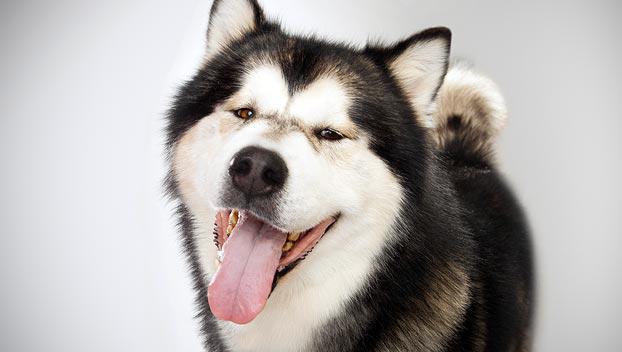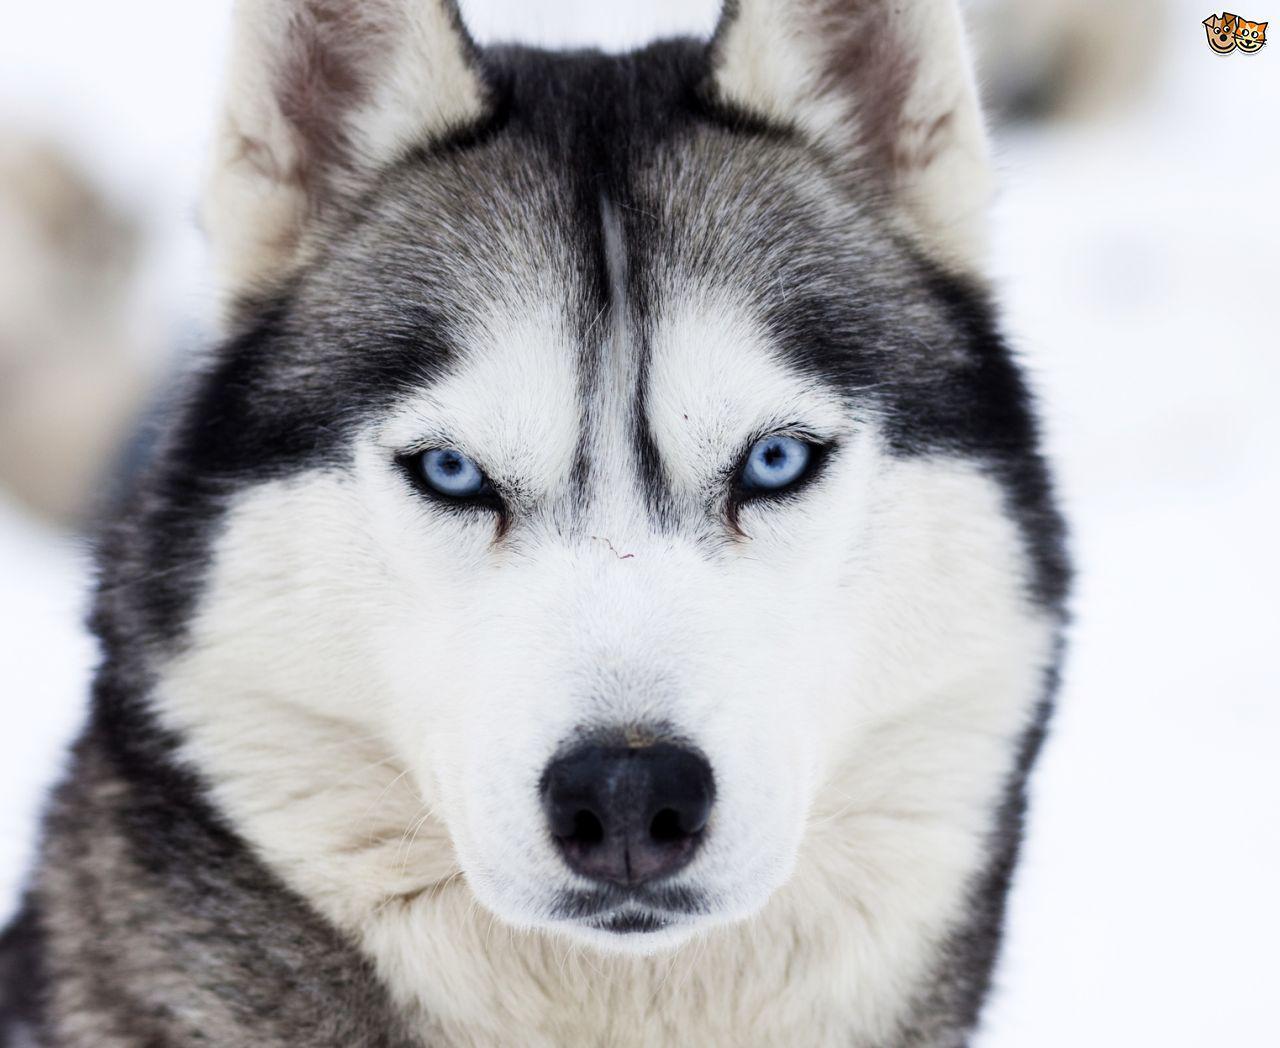The first image is the image on the left, the second image is the image on the right. Considering the images on both sides, is "In the image to the right you can see the dog's tongue." valid? Answer yes or no. No. The first image is the image on the left, the second image is the image on the right. Evaluate the accuracy of this statement regarding the images: "Each image features only one dog, and the dog on the left has an open mouth, while the dog on the right has a closed mouth.". Is it true? Answer yes or no. Yes. 